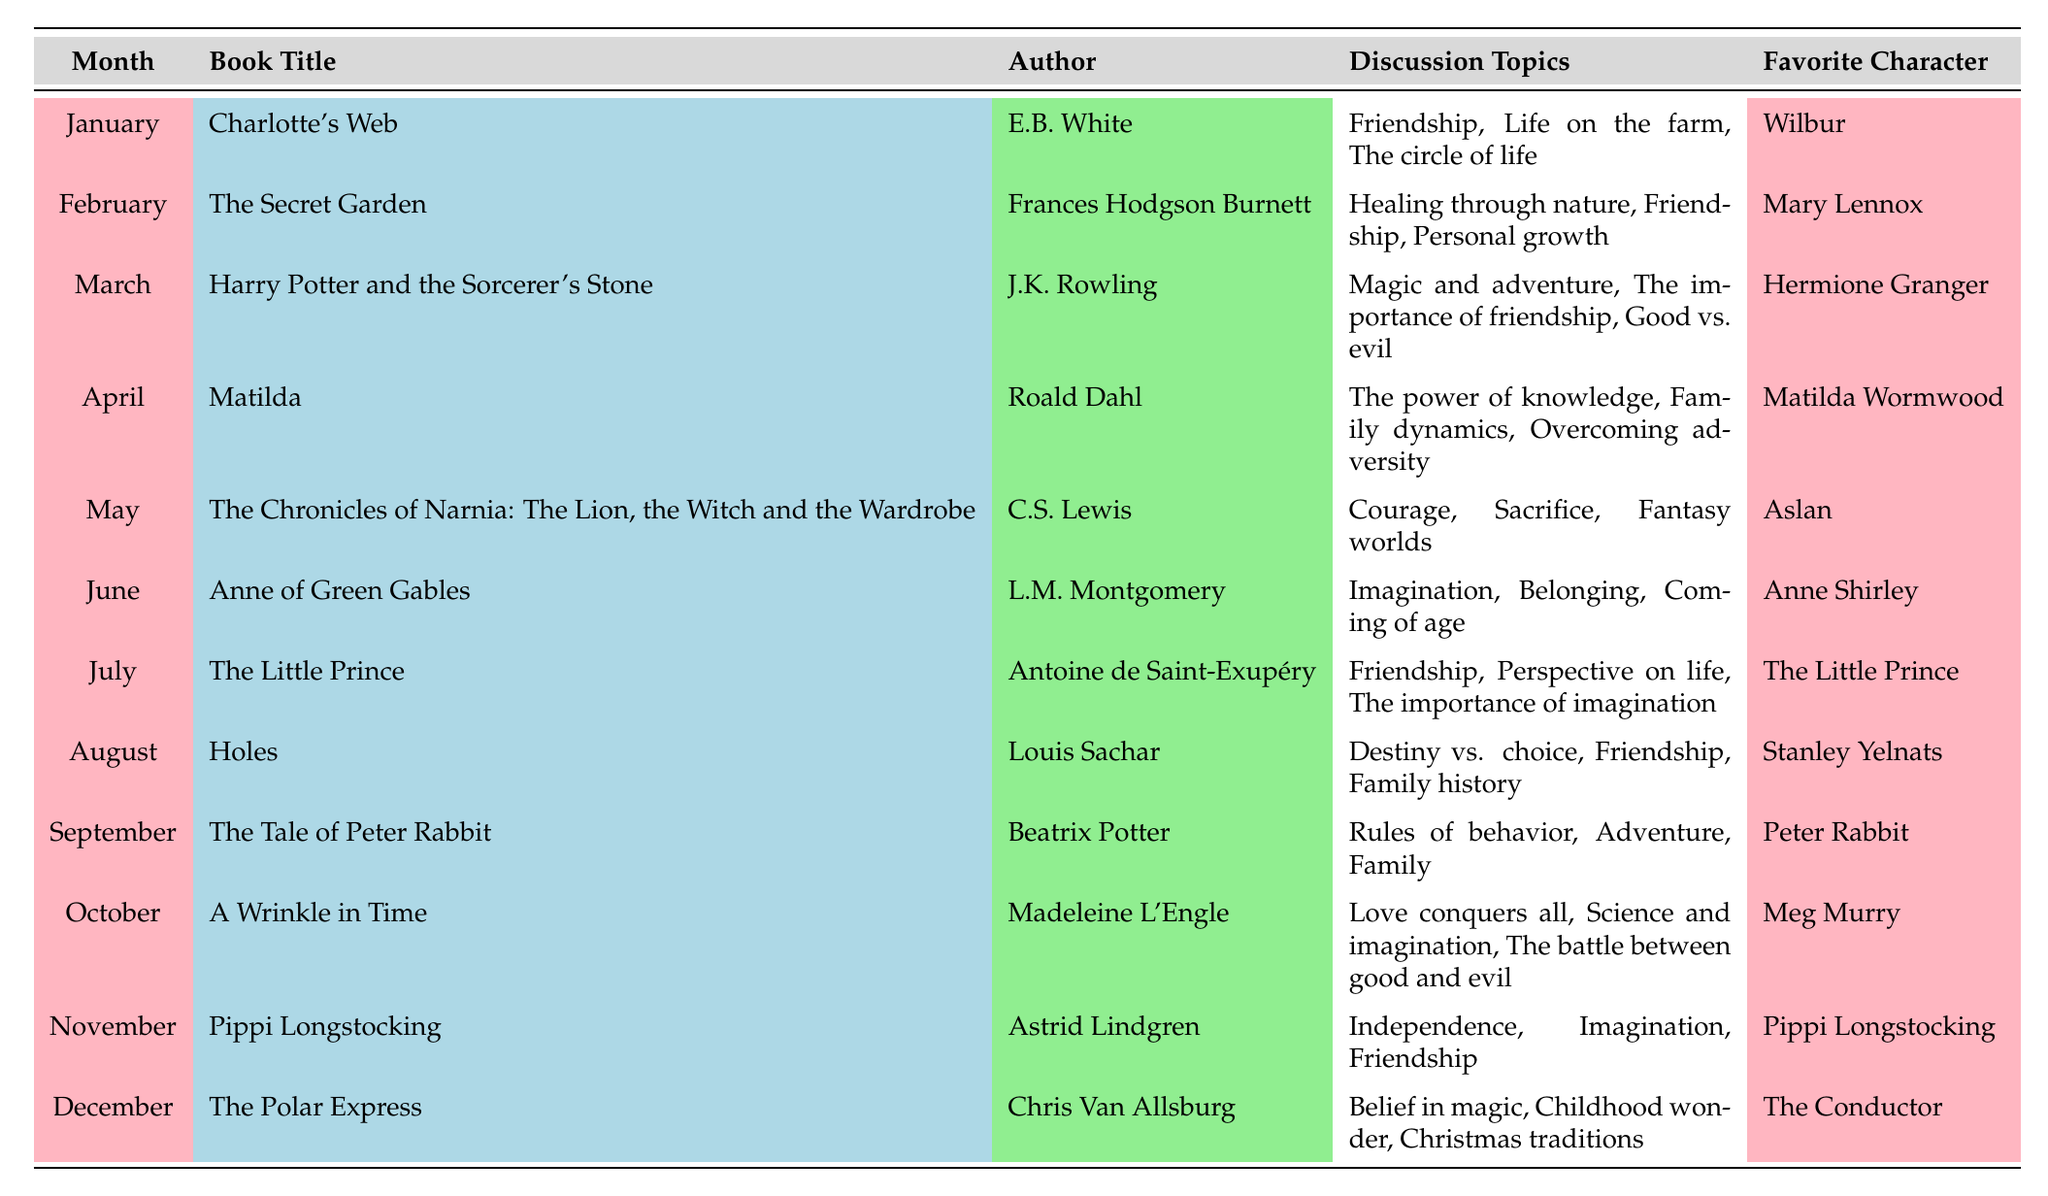What book was selected for September? The table lists "The Tale of Peter Rabbit" as the book selected for September.
Answer: The Tale of Peter Rabbit Who is the author of "The Secret Garden"? Looking at the table, "The Secret Garden" was written by Frances Hodgson Burnett.
Answer: Frances Hodgson Burnett Which character is favored in the book "Matilda"? According to the table, the favorite character in "Matilda" is Matilda Wormwood.
Answer: Matilda Wormwood How many books focus on the theme of friendship? By counting the discussion topics in the table, "Charlotte's Web," "The Secret Garden," "Harry Potter and the Sorcerer's Stone," "The Little Prince," "Holes," "The Tale of Peter Rabbit," "A Wrinkle in Time," "Pippi Longstocking" all mention friendship, totaling 8 books.
Answer: 8 In which month does the book "A Wrinkle in Time" get discussed? The table clearly shows that "A Wrinkle in Time" is selected for discussion in October.
Answer: October Is "The Polar Express" the favorite book of any character mentioned? The favorite character in "The Polar Express" is The Conductor, which means the book does have a favorite character associated with it.
Answer: Yes What are the discussion topics for "The Chronicles of Narnia: The Lion, the Witch and the Wardrobe"? The table lists the discussion topics for this book as Courage, Sacrifice, and Fantasy worlds.
Answer: Courage, Sacrifice, Fantasy worlds Which book discusses the theme of overcoming adversity? Referring to the table, "Matilda" is the book that discusses the theme of overcoming adversity in its discussion topics.
Answer: Matilda What is the favorite character for the book with the month of July? The table indicates that the favorite character in July's selection, "The Little Prince," is The Little Prince.
Answer: The Little Prince 